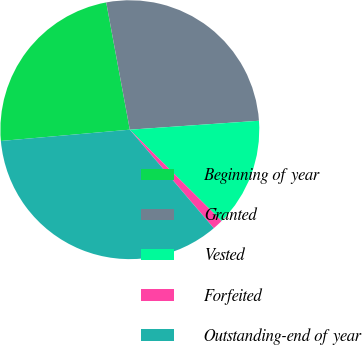<chart> <loc_0><loc_0><loc_500><loc_500><pie_chart><fcel>Beginning of year<fcel>Granted<fcel>Vested<fcel>Forfeited<fcel>Outstanding-end of year<nl><fcel>23.47%<fcel>26.82%<fcel>13.56%<fcel>1.31%<fcel>34.84%<nl></chart> 